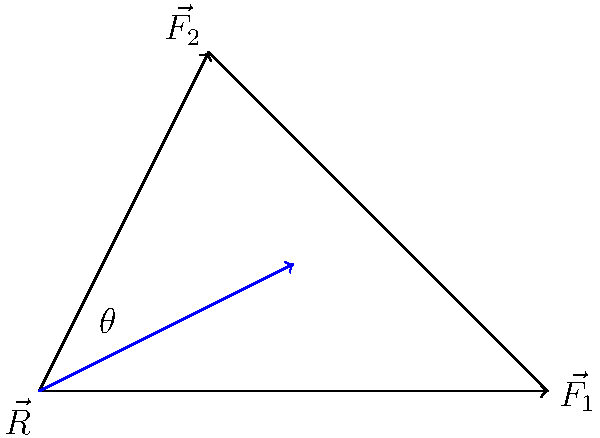In a physical altercation scenario, two officers apply forces $\vec{F_1}$ and $\vec{F_2}$ on a suspect as shown in the diagram. $\vec{F_1}$ has a magnitude of 300 N and $\vec{F_2}$ has a magnitude of 250 N. The angle between these forces is 60°. Calculate the magnitude of the resultant force $\vec{R}$ acting on the suspect. To solve this problem, we'll use the law of cosines, which is applicable when we have two vectors and the angle between them. The steps are as follows:

1) The law of cosines states that for a triangle with sides a, b, and c, and an angle C opposite the side c:

   $c^2 = a^2 + b^2 - 2ab \cos(C)$

2) In our case:
   - a = $|\vec{F_1}| = 300$ N
   - b = $|\vec{F_2}| = 250$ N
   - C = 60°
   - c = $|\vec{R}|$ (what we're solving for)

3) Plugging these values into the formula:

   $|\vec{R}|^2 = 300^2 + 250^2 - 2(300)(250)\cos(60°)$

4) Simplify:
   $|\vec{R}|^2 = 90000 + 62500 - 150000\cos(60°)$

5) $\cos(60°) = 0.5$, so:
   $|\vec{R}|^2 = 90000 + 62500 - 75000 = 77500$

6) Take the square root of both sides:
   $|\vec{R}| = \sqrt{77500} \approx 278.39$ N

Therefore, the magnitude of the resultant force is approximately 278.39 N.
Answer: 278.39 N 